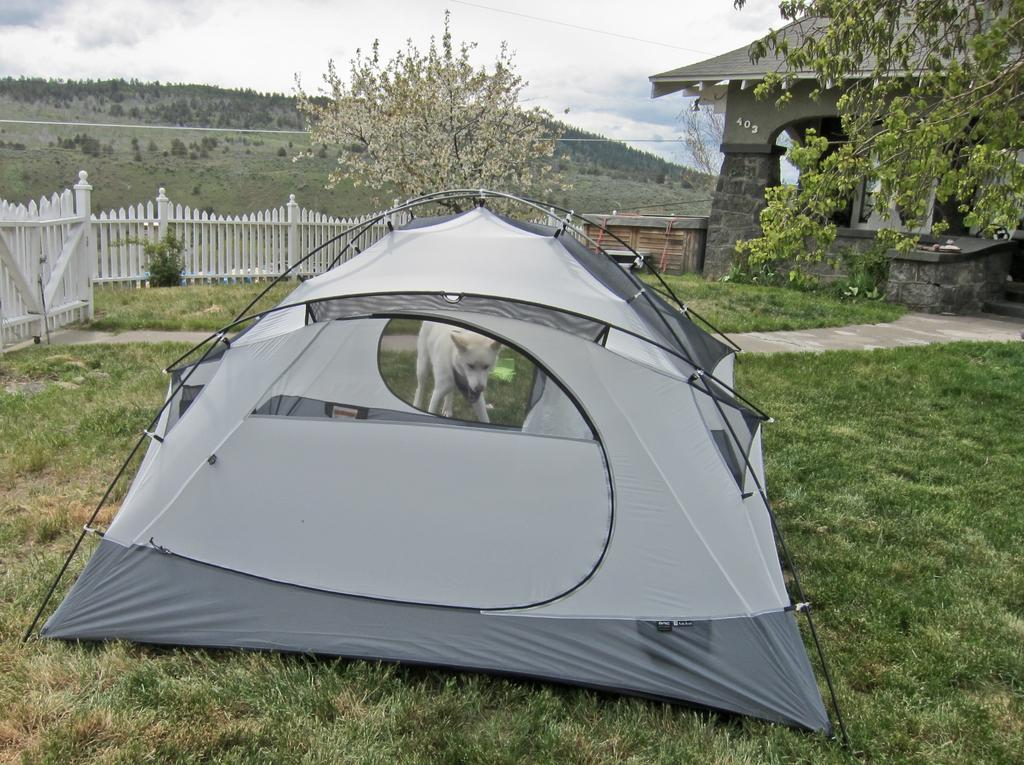What type of shelter is set up on the grass in the image? There is a tent on the grass in the image. What type of structure is also present in the image? There is a house in the image. What separates the grass from the house in the image? A fence is present in the image. What animal can be seen in the image? There is a dog in the image. What type of vegetation is visible in the image? Trees are visible in the image. What is visible at the top of the image? The sky is visible at the top of the image. What can be seen in the sky? Clouds are present in the sky. How many sisters are playing with the dog in the image? There are no sisters present in the image; only a dog is visible. What type of destruction is caused by the clouds in the image? The clouds do not cause any destruction in the image; they are simply visible in the sky. 